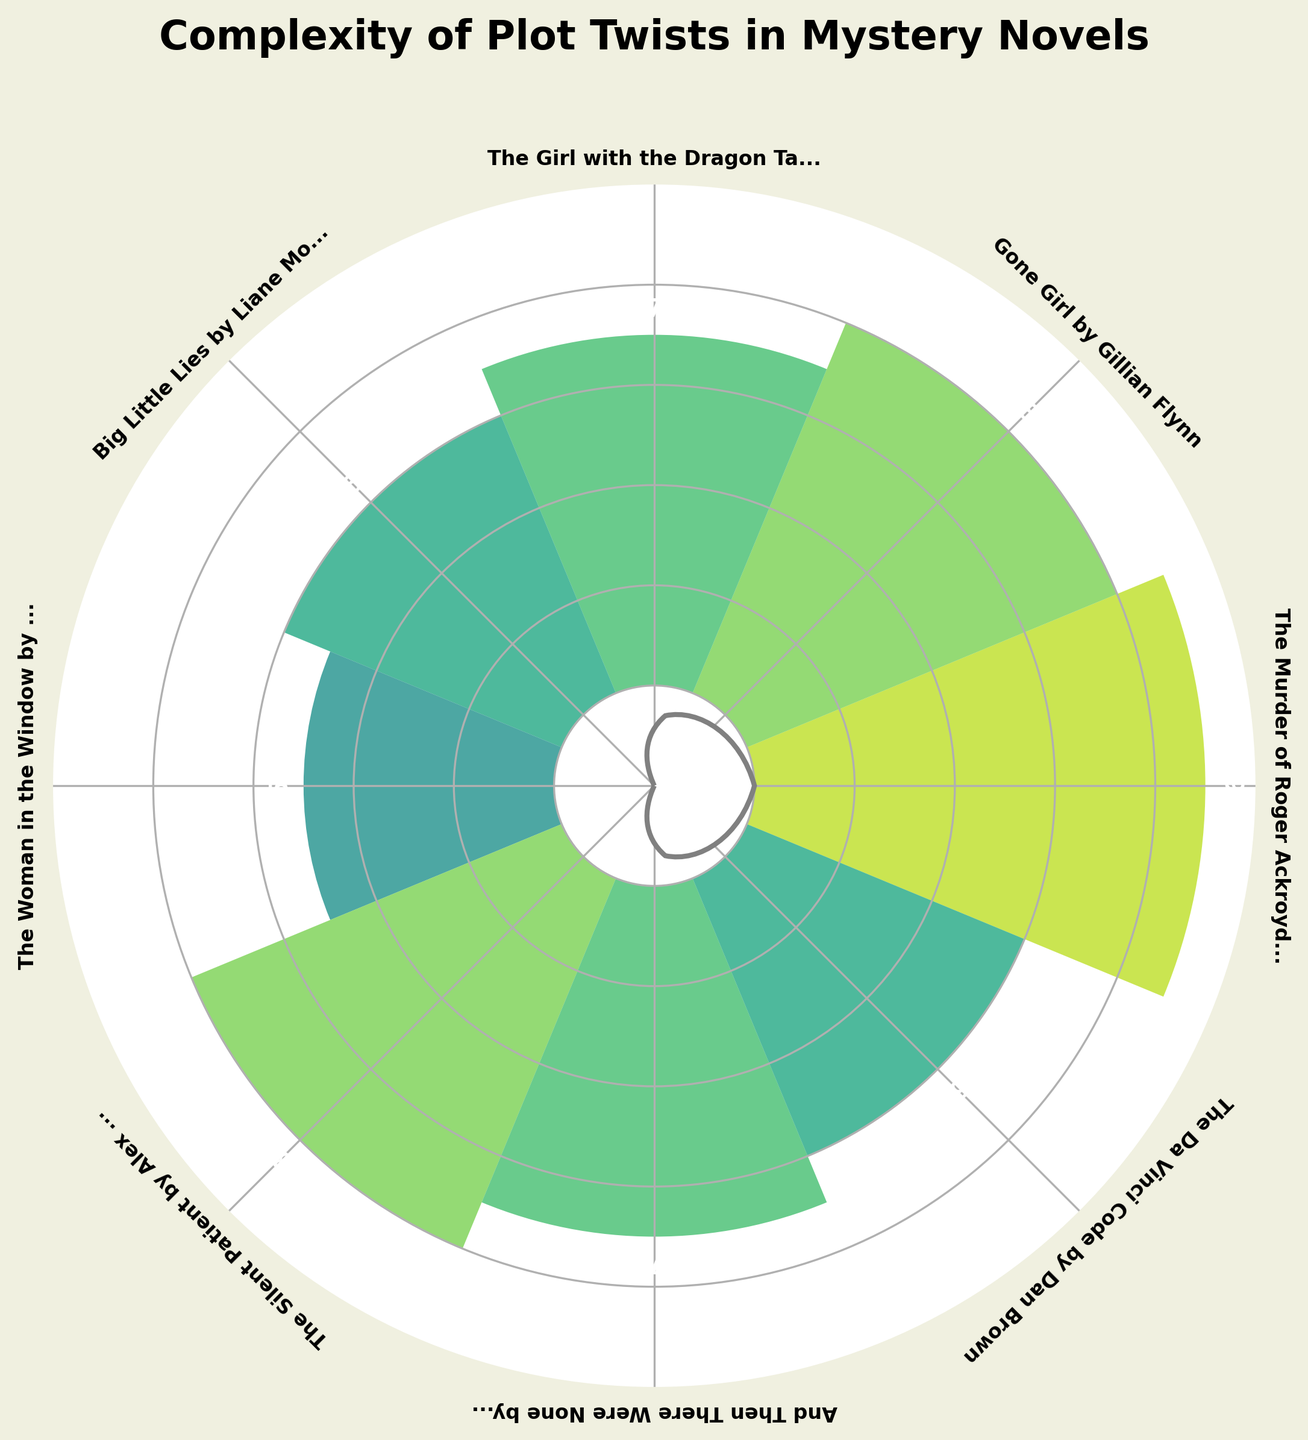what is the highest complexity level displayed on the plot? The highest complexity level is identified by looking at the bar that reaches the farthest from the center of the gauge. "The Murder of Roger Ackroyd" bar reaches a level of 9.
Answer: 9 Which novel has a complexity level of 5? By referring to the labels and the number inside the bars, "The Woman in the Window" is the novel with a complexity level of 5.
Answer: "The Woman in the Window" How many novels have a complexity level of 8? Count the bars that have the number 8 labeled on them. There are two such bars: "Gone Girl" and "The Silent Patient."
Answer: 2 What is the average complexity level of the novels? Sum the complexity levels and divide by the number of novels. (9 + 8 + 7 + 6 + 5 + 8 + 7 + 6) / 8 = 56 / 8 = 7.
Answer: 7 Does "And Then There Were None" by Agatha Christie have a higher or lower complexity level than "The Girl with the Dragon Tattoo" by Stieg Larsson? Compare the complexity levels indicated on the plot for both novels. Both have a complexity level of 7, so they are equal.
Answer: Equal Which novel has a higher complexity level: "Big Little Lies" or "The Da Vinci Code"? Compare the complexity levels indicated on the plot for both novels. Both novels have a complexity level of 6, so they are equal.
Answer: Equal What is the difference in complexity levels between "Gone Girl" by Gillian Flynn and "The Woman in the Window" by A.J. Finn? Subtract the complexity level of "The Woman in the Window" (5) from the complexity level of "Gone Girl" (8). 8 - 5 = 3.
Answer: 3 What is the title of the plot? The title is usually located at the top of the plot. It is "Complexity of Plot Twists in Mystery Novels."
Answer: "Complexity of Plot Twists in Mystery Novels" Which two novels have the same complexity level of 7? Identify the bars with the complexity level of 7. "The Girl with the Dragon Tattoo" and "And Then There Were None" both have a complexity level of 7.
Answer: "The Girl with the Dragon Tattoo" and "And Then There Were None" 